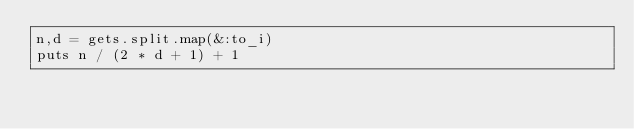<code> <loc_0><loc_0><loc_500><loc_500><_Ruby_>n,d = gets.split.map(&:to_i)
puts n / (2 * d + 1) + 1</code> 